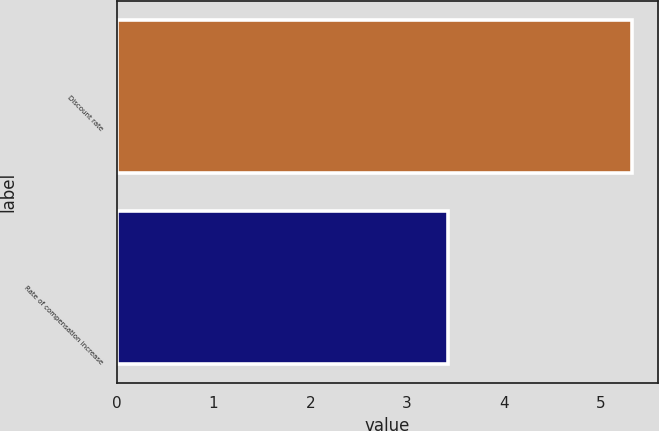<chart> <loc_0><loc_0><loc_500><loc_500><bar_chart><fcel>Discount rate<fcel>Rate of compensation increase<nl><fcel>5.33<fcel>3.42<nl></chart> 